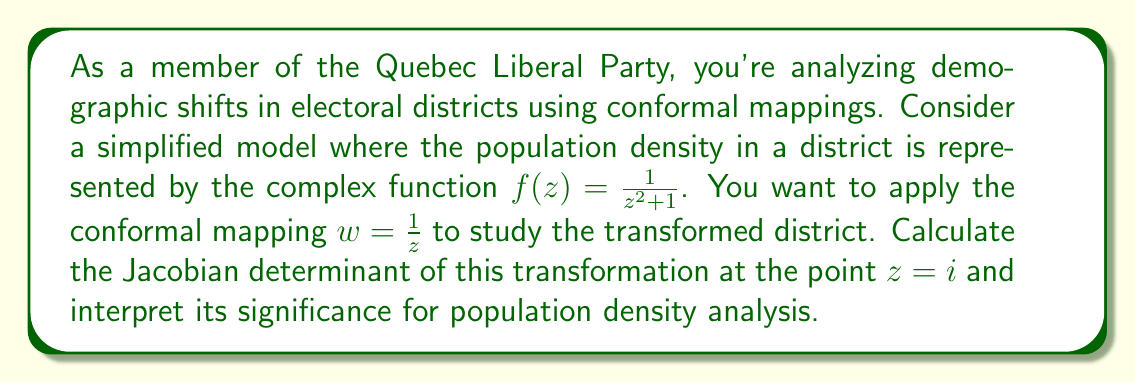Show me your answer to this math problem. To solve this problem, we'll follow these steps:

1) The conformal mapping is given by $w = \frac{1}{z}$. Let's express this as $u + iv = \frac{1}{x + iy}$.

2) To find the Jacobian, we need to calculate $\frac{\partial u}{\partial x}$, $\frac{\partial u}{\partial y}$, $\frac{\partial v}{\partial x}$, and $\frac{\partial v}{\partial y}$.

3) First, let's separate the real and imaginary parts:

   $\frac{1}{x + iy} = \frac{x - iy}{(x + iy)(x - iy)} = \frac{x - iy}{x^2 + y^2}$

   So, $u = \frac{x}{x^2 + y^2}$ and $v = -\frac{y}{x^2 + y^2}$

4) Now we can calculate the partial derivatives:

   $\frac{\partial u}{\partial x} = \frac{(x^2 + y^2) - 2x^2}{(x^2 + y^2)^2} = \frac{y^2 - x^2}{(x^2 + y^2)^2}$

   $\frac{\partial u}{\partial y} = \frac{-2xy}{(x^2 + y^2)^2}$

   $\frac{\partial v}{\partial x} = \frac{-2xy}{(x^2 + y^2)^2}$

   $\frac{\partial v}{\partial y} = \frac{-((x^2 + y^2) - 2y^2)}{(x^2 + y^2)^2} = \frac{x^2 - y^2}{(x^2 + y^2)^2}$

5) The Jacobian determinant is:

   $J = \frac{\partial u}{\partial x} \frac{\partial v}{\partial y} - \frac{\partial u}{\partial y} \frac{\partial v}{\partial x}$

6) Substituting the expressions we found:

   $J = (\frac{y^2 - x^2}{(x^2 + y^2)^2})(\frac{x^2 - y^2}{(x^2 + y^2)^2}) - (\frac{-2xy}{(x^2 + y^2)^2})(\frac{-2xy}{(x^2 + y^2)^2})$

   $= \frac{(y^2 - x^2)^2 + 4x^2y^2}{(x^2 + y^2)^4} = \frac{(x^2 + y^2)^2}{(x^2 + y^2)^4} = \frac{1}{(x^2 + y^2)^2}$

7) At the point $z = i$, we have $x = 0$ and $y = 1$. Substituting these values:

   $J|_{z=i} = \frac{1}{(0^2 + 1^2)^2} = 1$

8) Interpretation: The Jacobian determinant represents the factor by which the transformation scales areas. A value of 1 means that at the point $z = i$, the conformal mapping preserves areas. This implies that the population density at this point in the transformed district will be the same as in the original district. However, this is only true at this specific point. At other points, the Jacobian will generally not be 1, indicating that the transformation will change population densities differently across the district.
Answer: The Jacobian determinant of the conformal mapping $w = \frac{1}{z}$ at the point $z = i$ is 1. This means that at this specific point, the transformation preserves areas and therefore population densities. However, this local area preservation does not hold for the entire district, allowing for analysis of how population densities change across different regions of the transformed electoral district. 